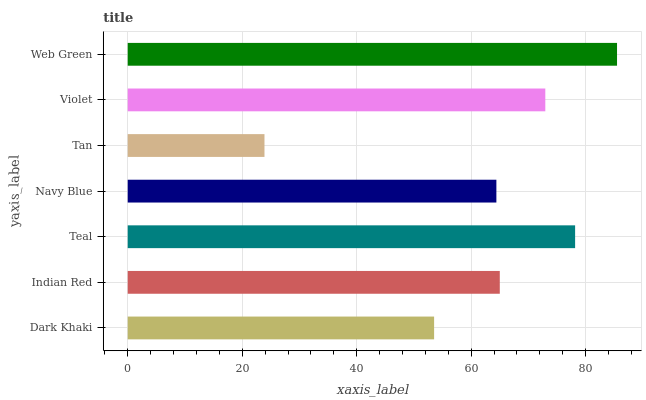Is Tan the minimum?
Answer yes or no. Yes. Is Web Green the maximum?
Answer yes or no. Yes. Is Indian Red the minimum?
Answer yes or no. No. Is Indian Red the maximum?
Answer yes or no. No. Is Indian Red greater than Dark Khaki?
Answer yes or no. Yes. Is Dark Khaki less than Indian Red?
Answer yes or no. Yes. Is Dark Khaki greater than Indian Red?
Answer yes or no. No. Is Indian Red less than Dark Khaki?
Answer yes or no. No. Is Indian Red the high median?
Answer yes or no. Yes. Is Indian Red the low median?
Answer yes or no. Yes. Is Violet the high median?
Answer yes or no. No. Is Navy Blue the low median?
Answer yes or no. No. 